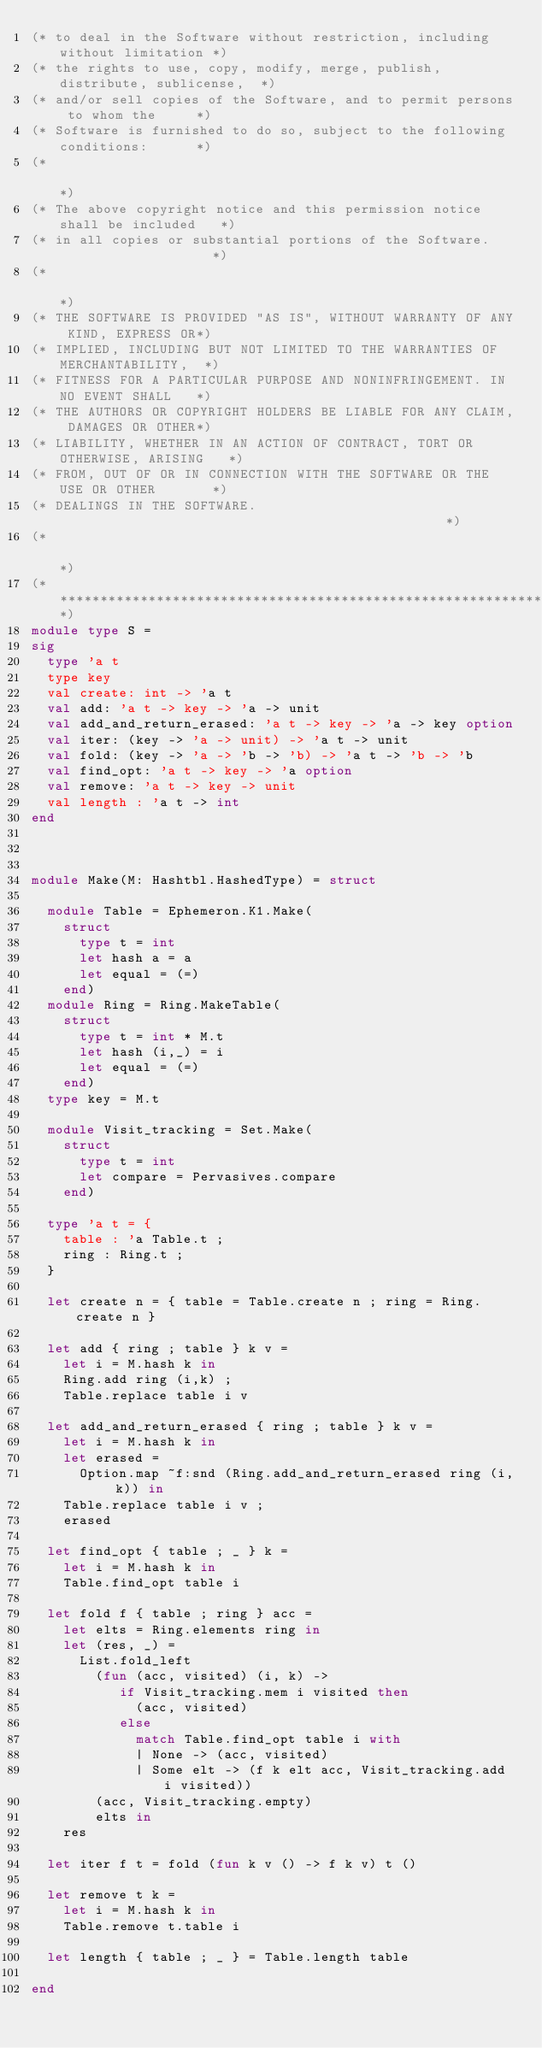Convert code to text. <code><loc_0><loc_0><loc_500><loc_500><_OCaml_>(* to deal in the Software without restriction, including without limitation *)
(* the rights to use, copy, modify, merge, publish, distribute, sublicense,  *)
(* and/or sell copies of the Software, and to permit persons to whom the     *)
(* Software is furnished to do so, subject to the following conditions:      *)
(*                                                                           *)
(* The above copyright notice and this permission notice shall be included   *)
(* in all copies or substantial portions of the Software.                    *)
(*                                                                           *)
(* THE SOFTWARE IS PROVIDED "AS IS", WITHOUT WARRANTY OF ANY KIND, EXPRESS OR*)
(* IMPLIED, INCLUDING BUT NOT LIMITED TO THE WARRANTIES OF MERCHANTABILITY,  *)
(* FITNESS FOR A PARTICULAR PURPOSE AND NONINFRINGEMENT. IN NO EVENT SHALL   *)
(* THE AUTHORS OR COPYRIGHT HOLDERS BE LIABLE FOR ANY CLAIM, DAMAGES OR OTHER*)
(* LIABILITY, WHETHER IN AN ACTION OF CONTRACT, TORT OR OTHERWISE, ARISING   *)
(* FROM, OUT OF OR IN CONNECTION WITH THE SOFTWARE OR THE USE OR OTHER       *)
(* DEALINGS IN THE SOFTWARE.                                                 *)
(*                                                                           *)
(*****************************************************************************)
module type S =
sig
  type 'a t
  type key
  val create: int -> 'a t
  val add: 'a t -> key -> 'a -> unit
  val add_and_return_erased: 'a t -> key -> 'a -> key option
  val iter: (key -> 'a -> unit) -> 'a t -> unit
  val fold: (key -> 'a -> 'b -> 'b) -> 'a t -> 'b -> 'b
  val find_opt: 'a t -> key -> 'a option
  val remove: 'a t -> key -> unit
  val length : 'a t -> int
end



module Make(M: Hashtbl.HashedType) = struct

  module Table = Ephemeron.K1.Make(
    struct
      type t = int
      let hash a = a
      let equal = (=)
    end)
  module Ring = Ring.MakeTable(
    struct
      type t = int * M.t
      let hash (i,_) = i
      let equal = (=)
    end)
  type key = M.t

  module Visit_tracking = Set.Make(
    struct
      type t = int
      let compare = Pervasives.compare
    end)

  type 'a t = {
    table : 'a Table.t ;
    ring : Ring.t ;
  }

  let create n = { table = Table.create n ; ring = Ring.create n }

  let add { ring ; table } k v =
    let i = M.hash k in
    Ring.add ring (i,k) ;
    Table.replace table i v

  let add_and_return_erased { ring ; table } k v =
    let i = M.hash k in
    let erased =
      Option.map ~f:snd (Ring.add_and_return_erased ring (i, k)) in
    Table.replace table i v ;
    erased

  let find_opt { table ; _ } k =
    let i = M.hash k in
    Table.find_opt table i

  let fold f { table ; ring } acc =
    let elts = Ring.elements ring in
    let (res, _) =
      List.fold_left
        (fun (acc, visited) (i, k) ->
           if Visit_tracking.mem i visited then
             (acc, visited)
           else
             match Table.find_opt table i with
             | None -> (acc, visited)
             | Some elt -> (f k elt acc, Visit_tracking.add i visited))
        (acc, Visit_tracking.empty)
        elts in
    res

  let iter f t = fold (fun k v () -> f k v) t ()

  let remove t k =
    let i = M.hash k in
    Table.remove t.table i

  let length { table ; _ } = Table.length table

end
</code> 